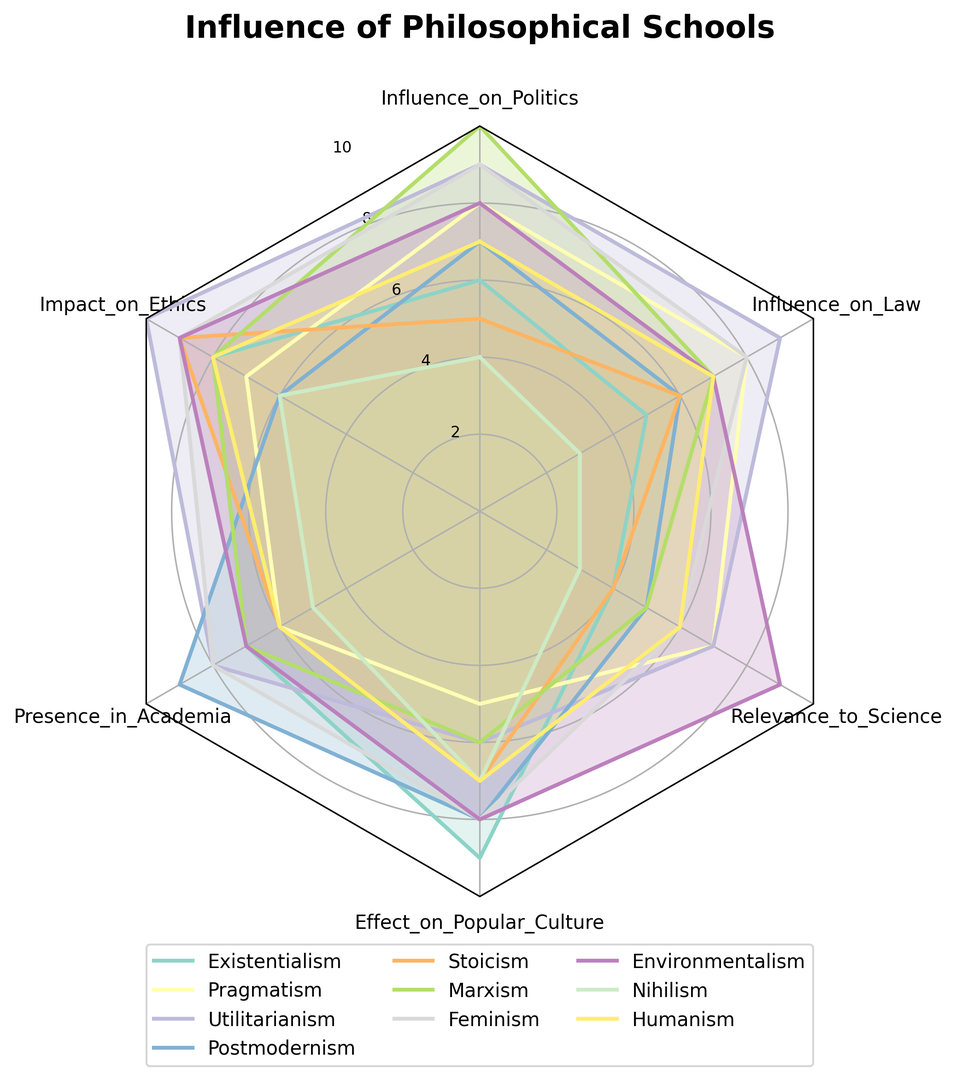What's the overall trend in Influence_on_Politics? Look at the Influence_on_Politics data points for each school of thought and notice which have the highest and lowest values. Existentialism is at 6, Pragmatism at 8, Utilitarianism at 9, Postmodernism at 7, Stoicism at 5, Marxism at 10, Feminism at 9, Environmentalism at 8, Nihilism at 4, and Humanism at 7. The trend indicates that Marxism has the highest influence at 10, while Nihilism has the lowest at 4.
Answer: Marxism is the highest, Nihilism is the lowest Which philosophical school scores highest in Impact_on_Ethics and what is its score? By looking at the Impact_on_Ethics values, we can see that Utilitarianism and Feminism each have scores of 10 and 9 respectively, which are notably high. Utilitarianism stands out with the highest score.
Answer: Utilitarianism, 10 Comparing Stoicism and Nihilism, which one has a higher Presence_in_Academia score? Look at the Presence_in_Academia scores for Stoicism and Nihilism. Stoicism has a score of 6, whereas Nihilism has a score of 5.
Answer: Stoicism What philosophical school has the highest overall score if you sum all its attributes? To find this, sum each school's scores across all categories:  
Existentialism: 39  
Pragmatism: 41  
Utilitarianism: 49  
Postmodernism: 41  
Stoicism: 37  
Marxism: 43  
Feminism: 48  
Environmentalism: 48  
Nihilism: 28  
Humanism: 41  
The highest overall score is Utilitarianism with 49.
Answer: Utilitarianism Which school has a better Relevance_to_Science, Environmentalism or Nihilism? Compare the Relevance_to_Science scores of Environmentalism and Nihilism. Environmentalism has a score of 9 while Nihilism has a score of 3.
Answer: Environmentalism What is the range of Influence_on_Law scores? The Influence_on_Law scores range from 3 (Nihilism) to 9 (Utilitarianism and Feminism). Calculate the range by subtracting the smallest value from the largest: 9 - 3 = 6.
Answer: 6 What is the average Presence_in_Academia score across all philosophical schools? Sum all the Presence_in_Academia scores: 7 + 6 + 8 + 9 + 6 + 7 + 8 + 7 + 5 + 6 = 69. Divide by the number of scores (10) to get the average. 69 / 10 = 6.9.
Answer: 6.9 Which philosophical schools have both an Influence_on_Politics and Impact_on_Ethics score of 8 or higher? Check which schools have scores of 8 or higher in both categories. Pragmatism (8, 7), Utilitarianism (9, 10), Feminism (9, 9), and Environmentalism (8, 9). Only Utilitarianism (9, 10), Feminism (9, 9), and Environmentalism (8, 9) meet both criteria.
Answer: Utilitarianism, Feminism, Environmentalism Which has the higher effect on popular culture, Stoicism or Postmodernism? Compare the Effect_on_Popular_Culture scores. Stoicism has 7, while Postmodernism has 8.
Answer: Postmodernism How does Humanism compare to Feminism in terms of overall Influence_on_Politics and Presence_in_Academia? Compare Humanism's Influence_on_Politics (7) and Presence_in_Academia (6) to Feminism's Influence_on_Politics (9) and Presence_in_Academia (8). Feminism scores higher in both categories.
Answer: Feminism 